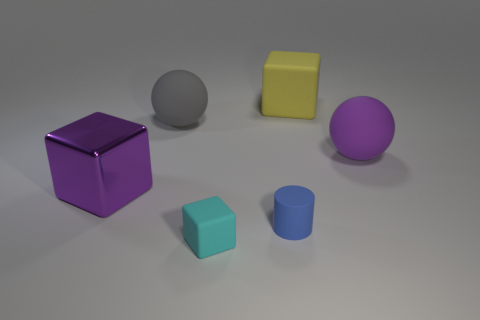Add 1 green metal blocks. How many objects exist? 7 Subtract all cylinders. How many objects are left? 5 Add 1 large cubes. How many large cubes exist? 3 Subtract 1 gray spheres. How many objects are left? 5 Subtract all large yellow blocks. Subtract all big yellow objects. How many objects are left? 4 Add 2 purple balls. How many purple balls are left? 3 